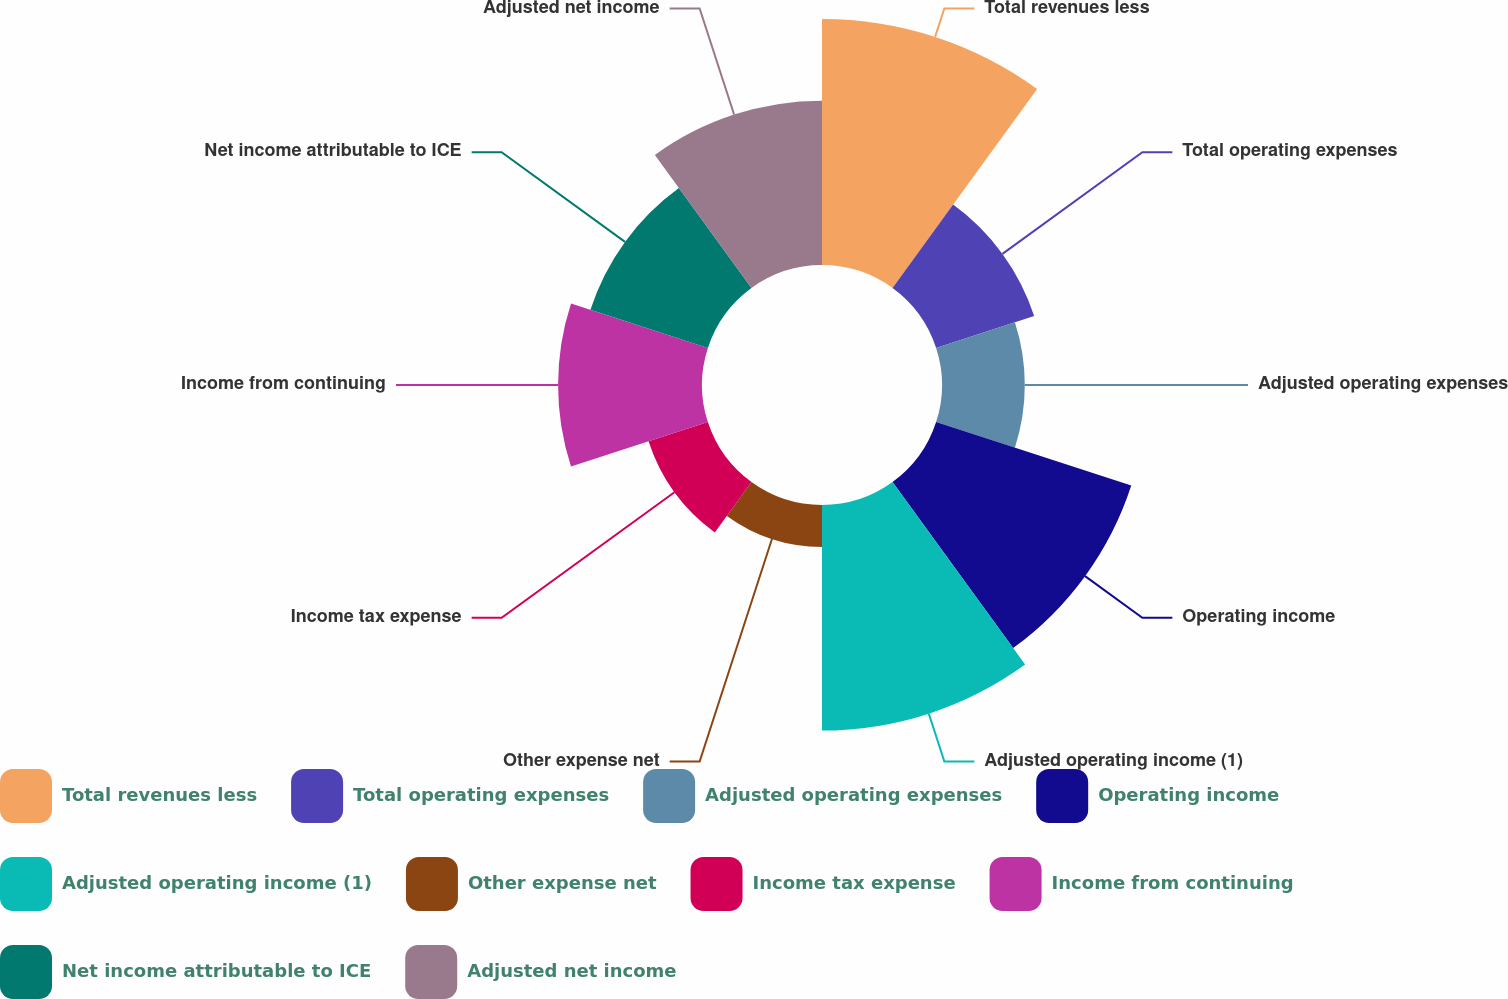Convert chart to OTSL. <chart><loc_0><loc_0><loc_500><loc_500><pie_chart><fcel>Total revenues less<fcel>Total operating expenses<fcel>Adjusted operating expenses<fcel>Operating income<fcel>Adjusted operating income (1)<fcel>Other expense net<fcel>Income tax expense<fcel>Income from continuing<fcel>Net income attributable to ICE<fcel>Adjusted net income<nl><fcel>17.59%<fcel>7.37%<fcel>5.92%<fcel>14.67%<fcel>16.13%<fcel>3.0%<fcel>4.46%<fcel>10.29%<fcel>8.83%<fcel>11.75%<nl></chart> 